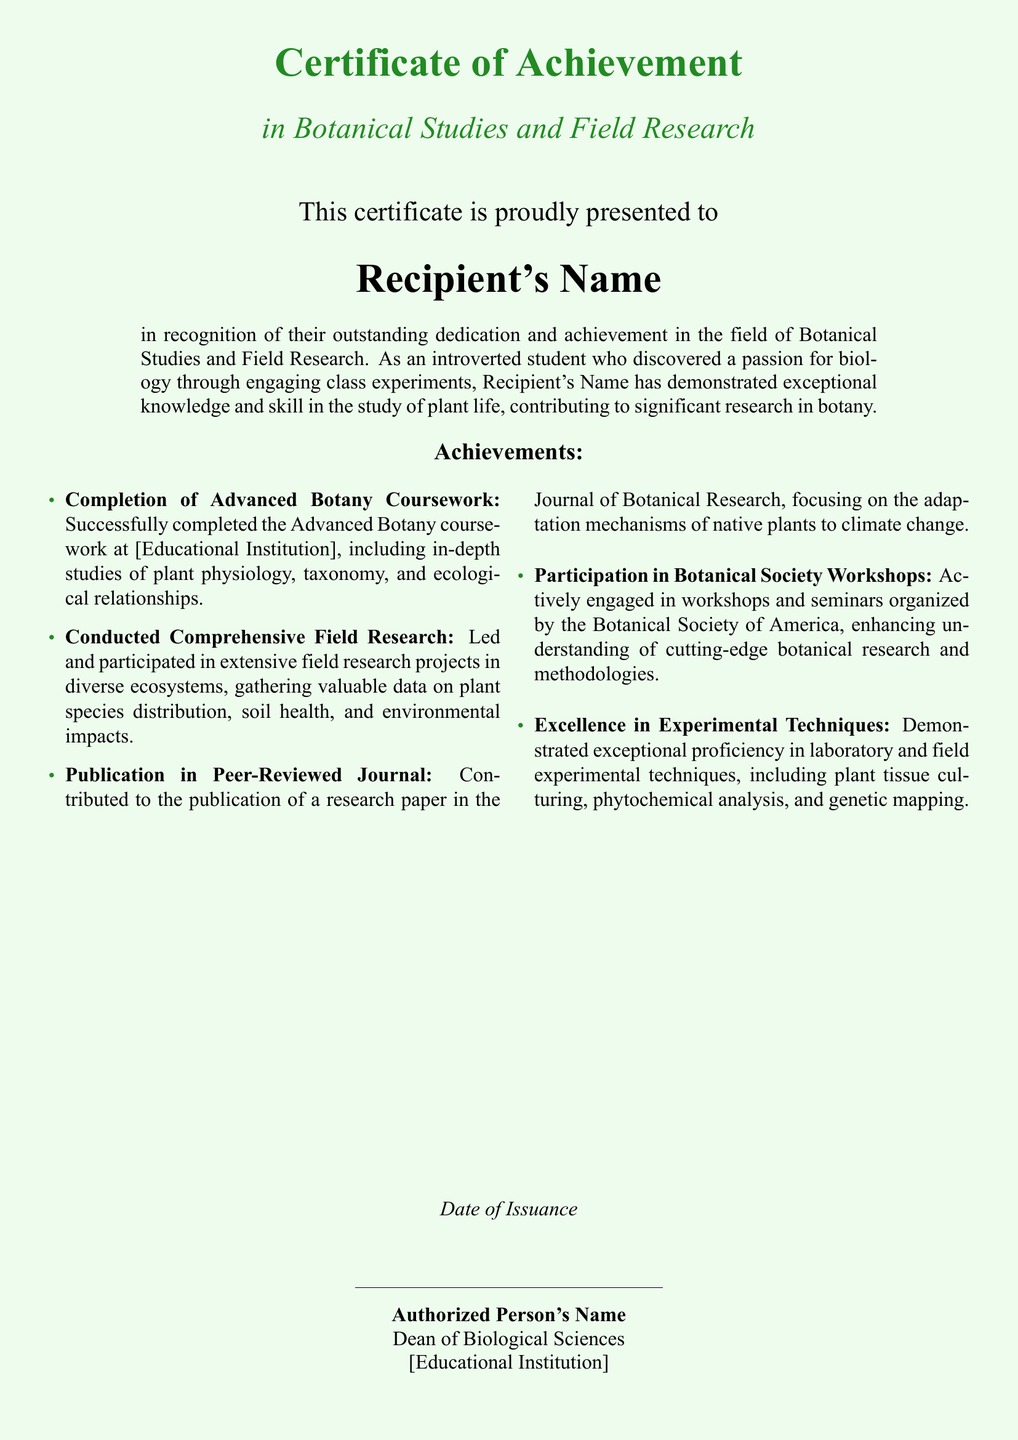what is the title of the certificate? The title of the certificate is prominently displayed at the top of the document.
Answer: Certificate of Achievement who is the recipient of the certificate? The recipient's name is indicated in a designated area on the certificate.
Answer: Recipient's Name what field does this certificate pertain to? The area of study related to this certificate is mentioned below the title.
Answer: Botanical Studies and Field Research how many achievements are listed in the document? The document includes a specific section outlining various achievements made by the recipient.
Answer: Five which journal published the recipient's research paper? The journal title is mentioned in the achievements section regarding publication.
Answer: Journal of Botanical Research who authorized the certificate? The authorized person's name is found towards the end of the document.
Answer: Authorized Person's Name what is the date of issuance? The date of issuance is indicated in a specific line within the document.
Answer: Date of Issuance what educational institution is mentioned in the document? The name of the educational institution appears in the context of the achievements and the authorized signature.
Answer: [Educational Institution] 